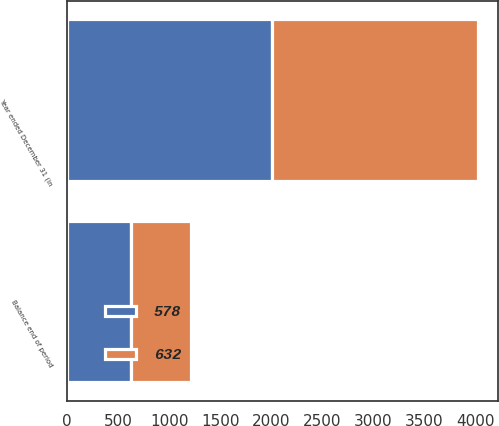Convert chart. <chart><loc_0><loc_0><loc_500><loc_500><stacked_bar_chart><ecel><fcel>Year ended December 31 (in<fcel>Balance end of period<nl><fcel>578<fcel>2010<fcel>632<nl><fcel>632<fcel>2009<fcel>578<nl></chart> 